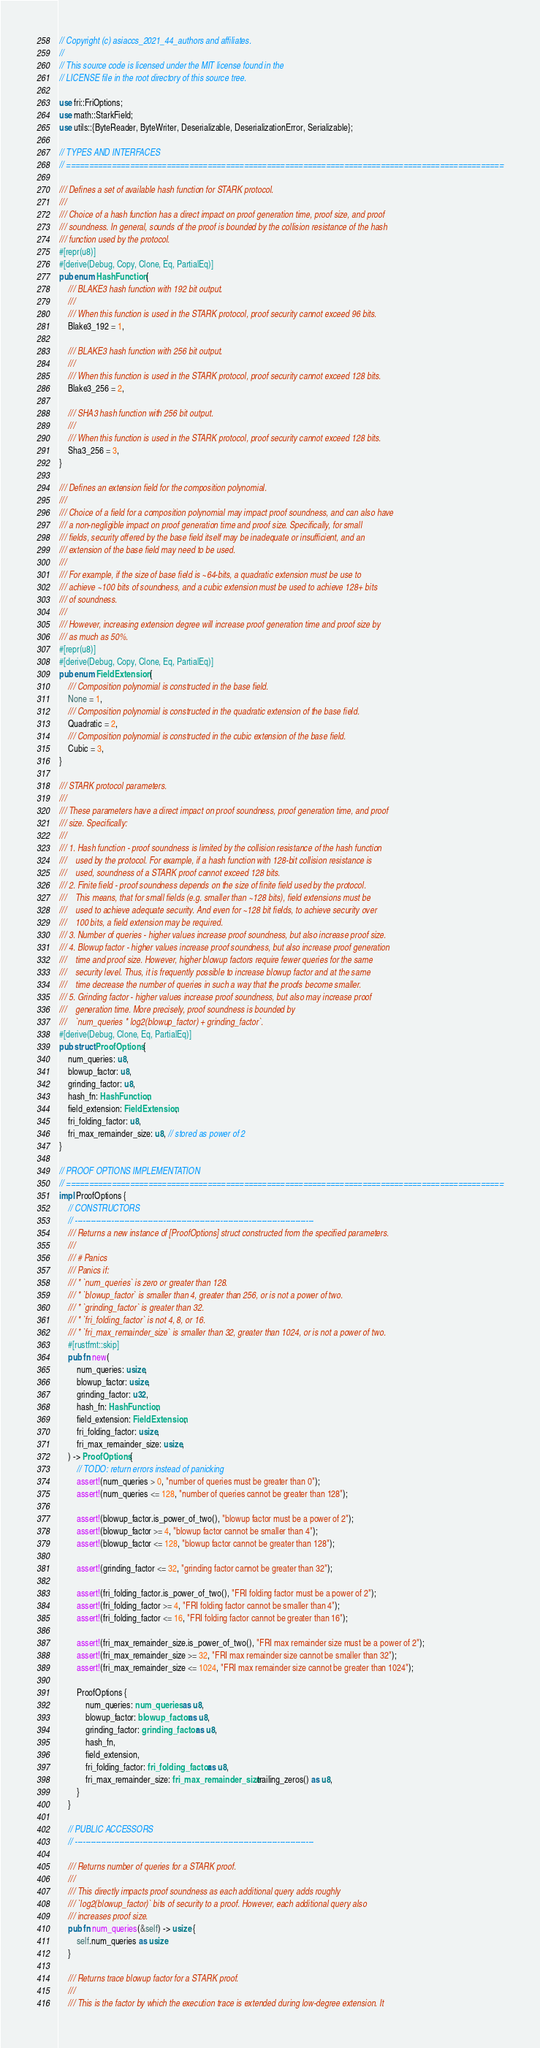Convert code to text. <code><loc_0><loc_0><loc_500><loc_500><_Rust_>// Copyright (c) asiaccs_2021_44_authors and affiliates.
//
// This source code is licensed under the MIT license found in the
// LICENSE file in the root directory of this source tree.

use fri::FriOptions;
use math::StarkField;
use utils::{ByteReader, ByteWriter, Deserializable, DeserializationError, Serializable};

// TYPES AND INTERFACES
// ================================================================================================

/// Defines a set of available hash function for STARK protocol.
///
/// Choice of a hash function has a direct impact on proof generation time, proof size, and proof
/// soundness. In general, sounds of the proof is bounded by the collision resistance of the hash
/// function used by the protocol.
#[repr(u8)]
#[derive(Debug, Copy, Clone, Eq, PartialEq)]
pub enum HashFunction {
    /// BLAKE3 hash function with 192 bit output.
    ///
    /// When this function is used in the STARK protocol, proof security cannot exceed 96 bits.
    Blake3_192 = 1,

    /// BLAKE3 hash function with 256 bit output.
    ///
    /// When this function is used in the STARK protocol, proof security cannot exceed 128 bits.
    Blake3_256 = 2,

    /// SHA3 hash function with 256 bit output.
    ///
    /// When this function is used in the STARK protocol, proof security cannot exceed 128 bits.
    Sha3_256 = 3,
}

/// Defines an extension field for the composition polynomial.
///
/// Choice of a field for a composition polynomial may impact proof soundness, and can also have
/// a non-negligible impact on proof generation time and proof size. Specifically, for small
/// fields, security offered by the base field itself may be inadequate or insufficient, and an
/// extension of the base field may need to be used.
///
/// For example, if the size of base field is ~64-bits, a quadratic extension must be use to
/// achieve ~100 bits of soundness, and a cubic extension must be used to achieve 128+ bits
/// of soundness.
///
/// However, increasing extension degree will increase proof generation time and proof size by
/// as much as 50%.
#[repr(u8)]
#[derive(Debug, Copy, Clone, Eq, PartialEq)]
pub enum FieldExtension {
    /// Composition polynomial is constructed in the base field.
    None = 1,
    /// Composition polynomial is constructed in the quadratic extension of the base field.
    Quadratic = 2,
    /// Composition polynomial is constructed in the cubic extension of the base field.
    Cubic = 3,
}

/// STARK protocol parameters.
///
/// These parameters have a direct impact on proof soundness, proof generation time, and proof
/// size. Specifically:
///
/// 1. Hash function - proof soundness is limited by the collision resistance of the hash function
///    used by the protocol. For example, if a hash function with 128-bit collision resistance is
///    used, soundness of a STARK proof cannot exceed 128 bits.
/// 2. Finite field - proof soundness depends on the size of finite field used by the protocol.
///    This means, that for small fields (e.g. smaller than ~128 bits), field extensions must be
///    used to achieve adequate security. And even for ~128 bit fields, to achieve security over
///    100 bits, a field extension may be required.
/// 3. Number of queries - higher values increase proof soundness, but also increase proof size.
/// 4. Blowup factor - higher values increase proof soundness, but also increase proof generation
///    time and proof size. However, higher blowup factors require fewer queries for the same
///    security level. Thus, it is frequently possible to increase blowup factor and at the same
///    time decrease the number of queries in such a way that the proofs become smaller.
/// 5. Grinding factor - higher values increase proof soundness, but also may increase proof
///    generation time. More precisely, proof soundness is bounded by
///    `num_queries * log2(blowup_factor) + grinding_factor`.
#[derive(Debug, Clone, Eq, PartialEq)]
pub struct ProofOptions {
    num_queries: u8,
    blowup_factor: u8,
    grinding_factor: u8,
    hash_fn: HashFunction,
    field_extension: FieldExtension,
    fri_folding_factor: u8,
    fri_max_remainder_size: u8, // stored as power of 2
}

// PROOF OPTIONS IMPLEMENTATION
// ================================================================================================
impl ProofOptions {
    // CONSTRUCTORS
    // --------------------------------------------------------------------------------------------
    /// Returns a new instance of [ProofOptions] struct constructed from the specified parameters.
    ///
    /// # Panics
    /// Panics if:
    /// * `num_queries` is zero or greater than 128.
    /// * `blowup_factor` is smaller than 4, greater than 256, or is not a power of two.
    /// * `grinding_factor` is greater than 32.
    /// * `fri_folding_factor` is not 4, 8, or 16.
    /// * `fri_max_remainder_size` is smaller than 32, greater than 1024, or is not a power of two.
    #[rustfmt::skip]
    pub fn new(
        num_queries: usize,
        blowup_factor: usize,
        grinding_factor: u32,
        hash_fn: HashFunction,
        field_extension: FieldExtension,
        fri_folding_factor: usize,
        fri_max_remainder_size: usize,
    ) -> ProofOptions {
        // TODO: return errors instead of panicking
        assert!(num_queries > 0, "number of queries must be greater than 0");
        assert!(num_queries <= 128, "number of queries cannot be greater than 128");

        assert!(blowup_factor.is_power_of_two(), "blowup factor must be a power of 2");
        assert!(blowup_factor >= 4, "blowup factor cannot be smaller than 4");
        assert!(blowup_factor <= 128, "blowup factor cannot be greater than 128");

        assert!(grinding_factor <= 32, "grinding factor cannot be greater than 32");

        assert!(fri_folding_factor.is_power_of_two(), "FRI folding factor must be a power of 2");
        assert!(fri_folding_factor >= 4, "FRI folding factor cannot be smaller than 4");
        assert!(fri_folding_factor <= 16, "FRI folding factor cannot be greater than 16");

        assert!(fri_max_remainder_size.is_power_of_two(), "FRI max remainder size must be a power of 2");
        assert!(fri_max_remainder_size >= 32, "FRI max remainder size cannot be smaller than 32");
        assert!(fri_max_remainder_size <= 1024, "FRI max remainder size cannot be greater than 1024");

        ProofOptions {
            num_queries: num_queries as u8,
            blowup_factor: blowup_factor as u8,
            grinding_factor: grinding_factor as u8,
            hash_fn,
            field_extension,
            fri_folding_factor: fri_folding_factor as u8,
            fri_max_remainder_size: fri_max_remainder_size.trailing_zeros() as u8,
        }
    }

    // PUBLIC ACCESSORS
    // --------------------------------------------------------------------------------------------

    /// Returns number of queries for a STARK proof.
    ///
    /// This directly impacts proof soundness as each additional query adds roughly
    /// `log2(blowup_factor)` bits of security to a proof. However, each additional query also
    /// increases proof size.
    pub fn num_queries(&self) -> usize {
        self.num_queries as usize
    }

    /// Returns trace blowup factor for a STARK proof.
    ///
    /// This is the factor by which the execution trace is extended during low-degree extension. It</code> 